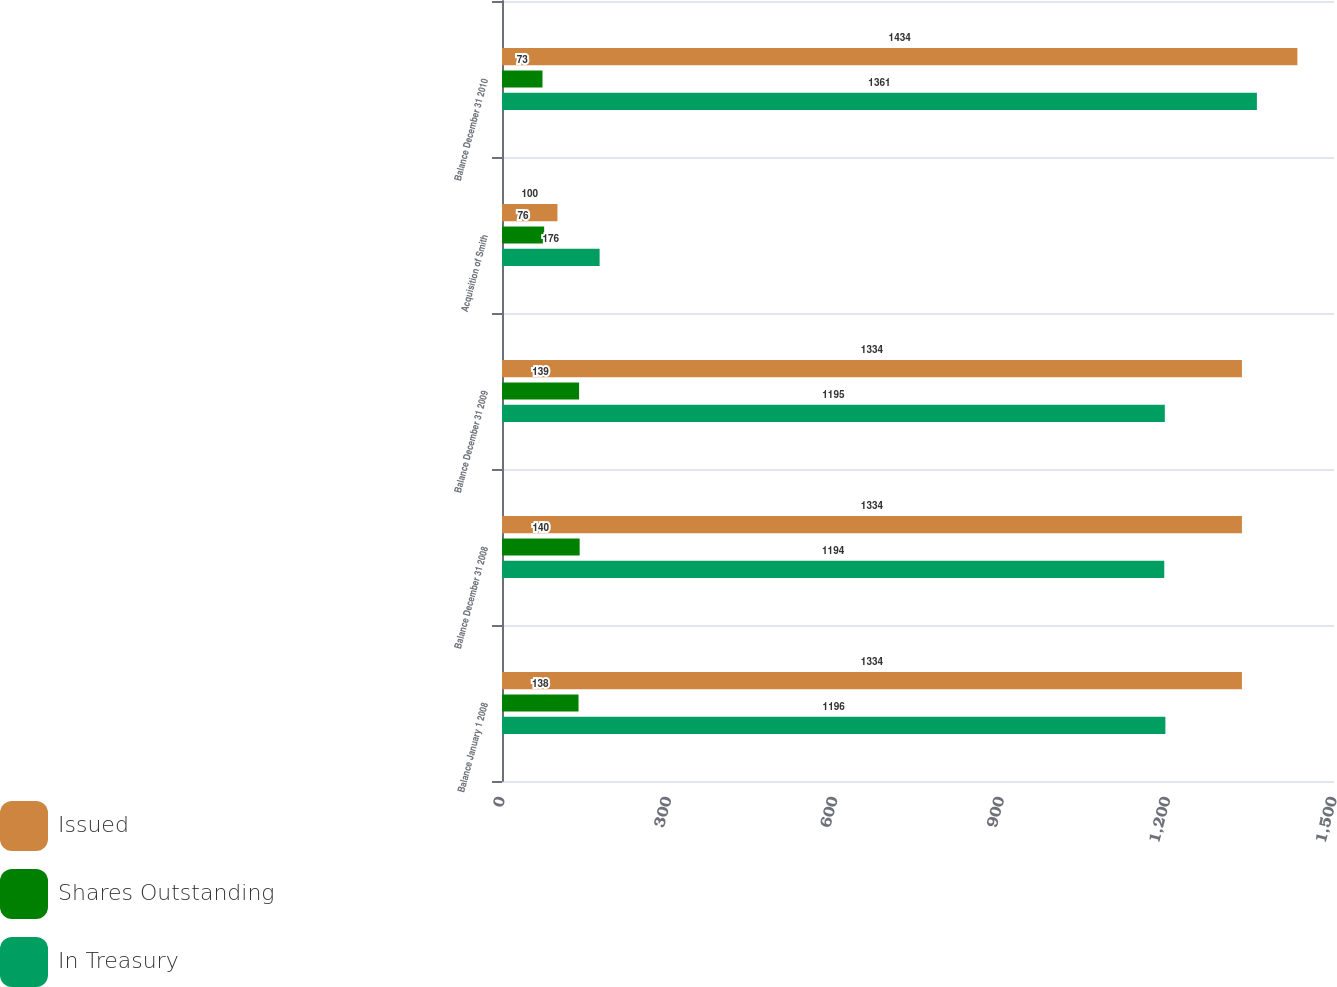Convert chart to OTSL. <chart><loc_0><loc_0><loc_500><loc_500><stacked_bar_chart><ecel><fcel>Balance January 1 2008<fcel>Balance December 31 2008<fcel>Balance December 31 2009<fcel>Acquisition of Smith<fcel>Balance December 31 2010<nl><fcel>Issued<fcel>1334<fcel>1334<fcel>1334<fcel>100<fcel>1434<nl><fcel>Shares Outstanding<fcel>138<fcel>140<fcel>139<fcel>76<fcel>73<nl><fcel>In Treasury<fcel>1196<fcel>1194<fcel>1195<fcel>176<fcel>1361<nl></chart> 